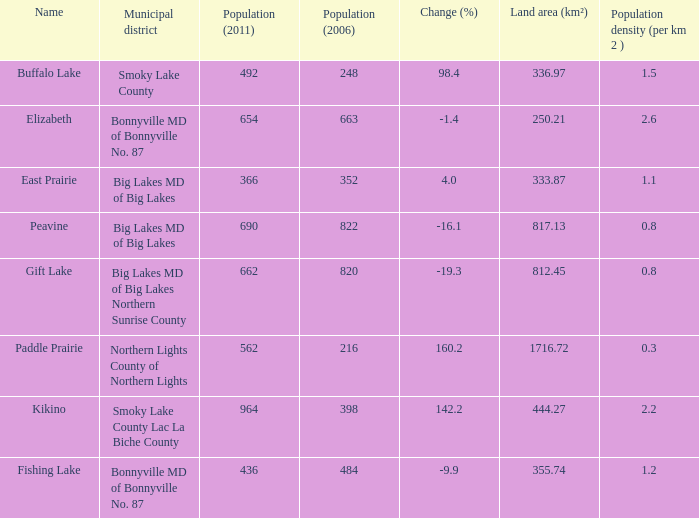What is the population per km in Smoky Lake County? 1.5. 